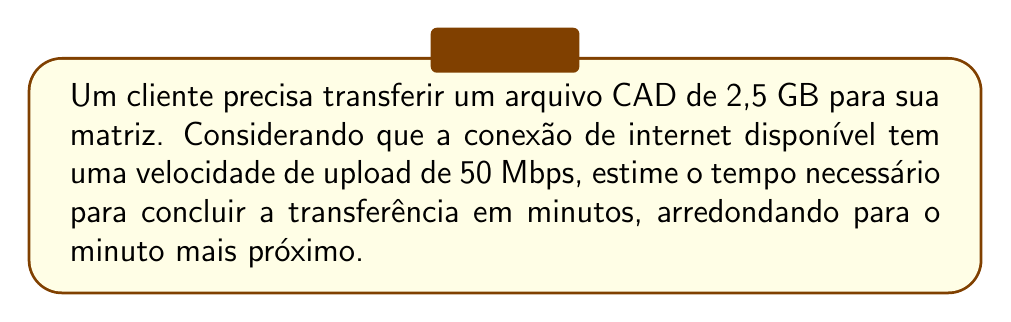Solve this math problem. Para resolver este problema, seguiremos os seguintes passos:

1) Primeiro, convertemos o tamanho do arquivo de GB para bits:
   $2,5 \text{ GB} = 2,5 \times 1024 \text{ MB} = 2560 \text{ MB}$
   $2560 \text{ MB} = 2560 \times 8 \text{ Mb} = 20480 \text{ Mb}$

2) A velocidade de upload é dada em Mbps (Megabits por segundo), então não precisamos converter.

3) Calculamos o tempo necessário dividindo o tamanho do arquivo pela velocidade de upload:
   $$\text{Tempo (segundos)} = \frac{\text{Tamanho do arquivo (Mb)}}{\text{Velocidade de upload (Mbps)}}$$
   $$\text{Tempo} = \frac{20480 \text{ Mb}}{50 \text{ Mbps}} = 409,6 \text{ segundos}$$

4) Convertemos o tempo de segundos para minutos:
   $$409,6 \text{ segundos} = \frac{409,6}{60} \text{ minutos} = 6,83 \text{ minutos}$$

5) Arredondamos para o minuto mais próximo:
   $6,83$ arredonda para $7$ minutos.
Answer: 7 minutos 